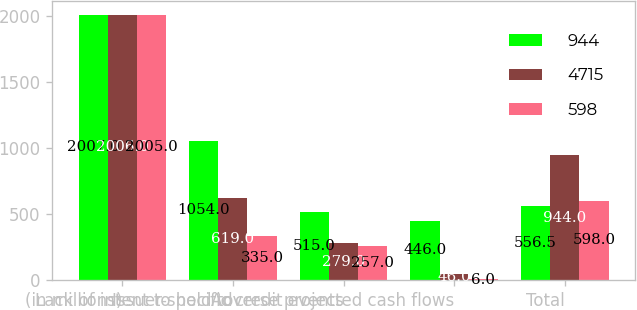Convert chart. <chart><loc_0><loc_0><loc_500><loc_500><stacked_bar_chart><ecel><fcel>(in millions)<fcel>Lack of intent to hold to<fcel>Issuer-specific credit events<fcel>Adverse projected cash flows<fcel>Total<nl><fcel>944<fcel>2007<fcel>1054<fcel>515<fcel>446<fcel>556.5<nl><fcel>4715<fcel>2006<fcel>619<fcel>279<fcel>46<fcel>944<nl><fcel>598<fcel>2005<fcel>335<fcel>257<fcel>6<fcel>598<nl></chart> 